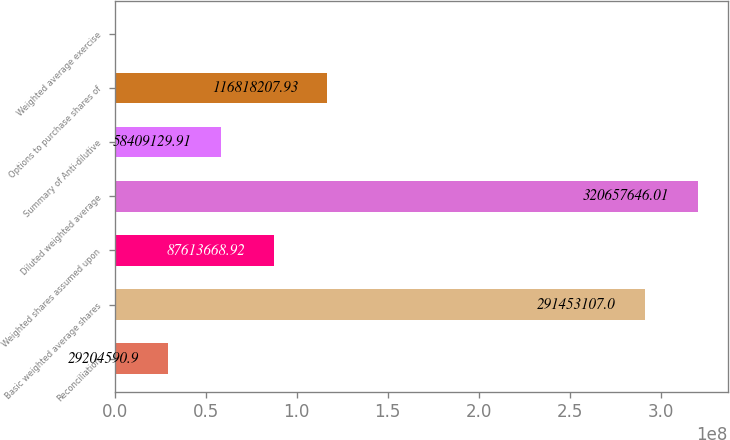<chart> <loc_0><loc_0><loc_500><loc_500><bar_chart><fcel>Reconciliation<fcel>Basic weighted average shares<fcel>Weighted shares assumed upon<fcel>Diluted weighted average<fcel>Summary of Anti-dilutive<fcel>Options to purchase shares of<fcel>Weighted average exercise<nl><fcel>2.92046e+07<fcel>2.91453e+08<fcel>8.76137e+07<fcel>3.20658e+08<fcel>5.84091e+07<fcel>1.16818e+08<fcel>51.89<nl></chart> 